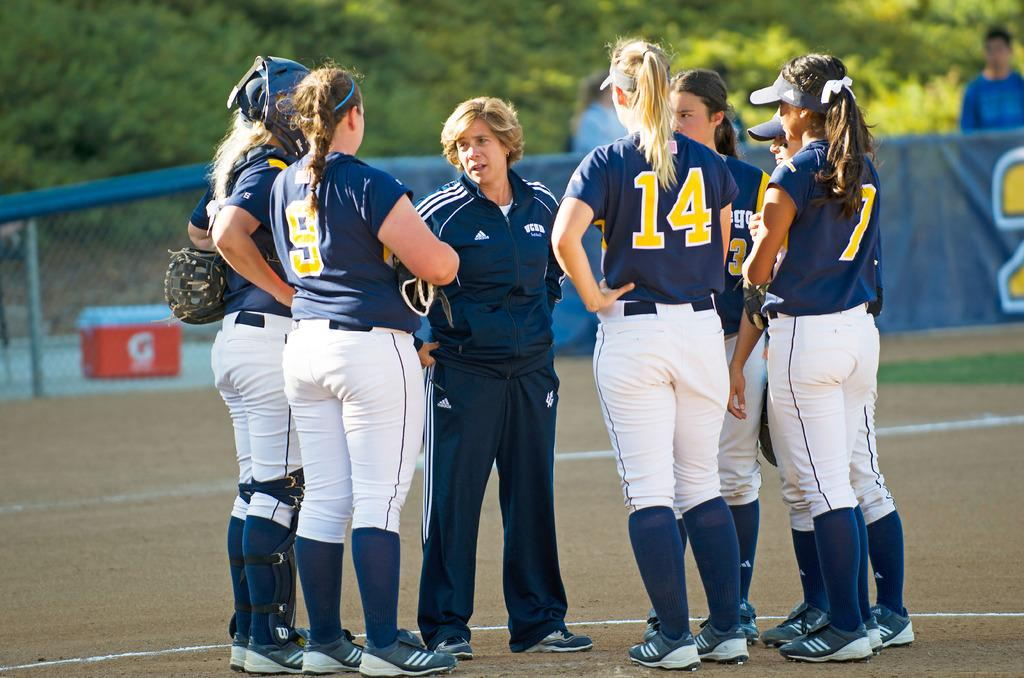<image>
Relay a brief, clear account of the picture shown. the number 14 stands with the other players in a circle 